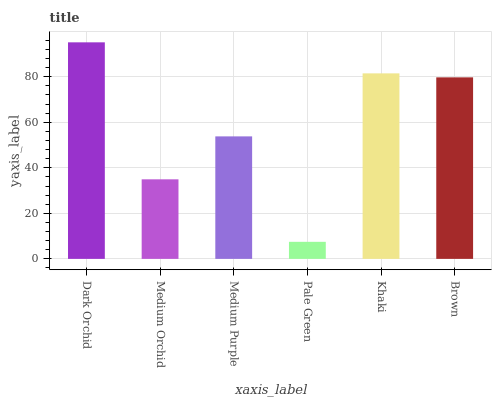Is Pale Green the minimum?
Answer yes or no. Yes. Is Dark Orchid the maximum?
Answer yes or no. Yes. Is Medium Orchid the minimum?
Answer yes or no. No. Is Medium Orchid the maximum?
Answer yes or no. No. Is Dark Orchid greater than Medium Orchid?
Answer yes or no. Yes. Is Medium Orchid less than Dark Orchid?
Answer yes or no. Yes. Is Medium Orchid greater than Dark Orchid?
Answer yes or no. No. Is Dark Orchid less than Medium Orchid?
Answer yes or no. No. Is Brown the high median?
Answer yes or no. Yes. Is Medium Purple the low median?
Answer yes or no. Yes. Is Pale Green the high median?
Answer yes or no. No. Is Dark Orchid the low median?
Answer yes or no. No. 